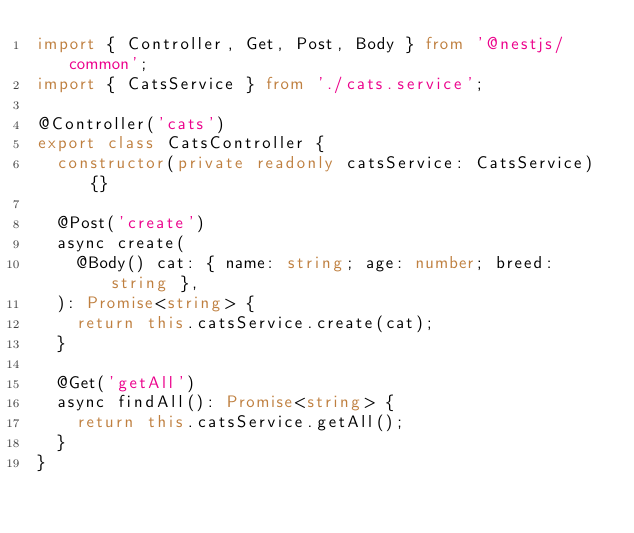Convert code to text. <code><loc_0><loc_0><loc_500><loc_500><_TypeScript_>import { Controller, Get, Post, Body } from '@nestjs/common';
import { CatsService } from './cats.service';

@Controller('cats')
export class CatsController {
  constructor(private readonly catsService: CatsService) {}

  @Post('create')
  async create(
    @Body() cat: { name: string; age: number; breed: string },
  ): Promise<string> {
    return this.catsService.create(cat);
  }

  @Get('getAll')
  async findAll(): Promise<string> {
    return this.catsService.getAll();
  }
}
</code> 